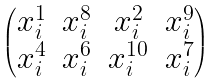<formula> <loc_0><loc_0><loc_500><loc_500>\begin{pmatrix} x _ { i } ^ { 1 } & x _ { i } ^ { 8 } & x _ { i } ^ { 2 } & x _ { i } ^ { 9 } \\ x _ { i } ^ { 4 } & x _ { i } ^ { 6 } & x _ { i } ^ { 1 0 } & x _ { i } ^ { 7 } \end{pmatrix}</formula> 